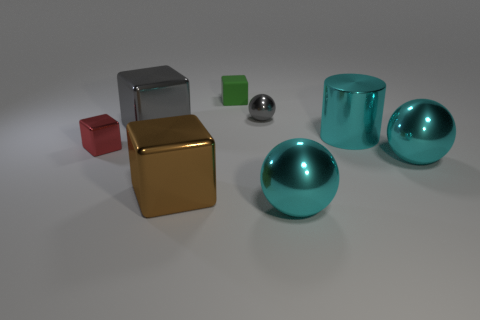Subtract all cyan spheres. Subtract all green cylinders. How many spheres are left? 1 Add 1 small things. How many objects exist? 9 Subtract all spheres. How many objects are left? 5 Subtract 0 yellow balls. How many objects are left? 8 Subtract all metallic cubes. Subtract all green rubber objects. How many objects are left? 4 Add 8 large cyan cylinders. How many large cyan cylinders are left? 9 Add 5 red metallic things. How many red metallic things exist? 6 